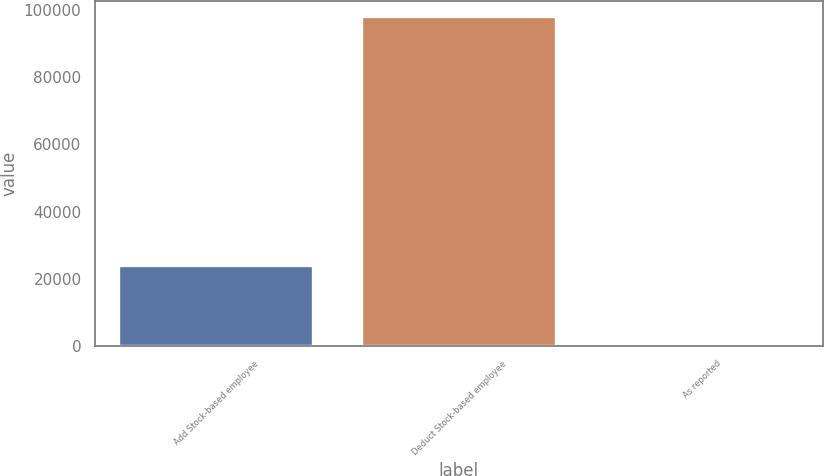Convert chart. <chart><loc_0><loc_0><loc_500><loc_500><bar_chart><fcel>Add Stock-based employee<fcel>Deduct Stock-based employee<fcel>As reported<nl><fcel>23805<fcel>97878<fcel>0.27<nl></chart> 